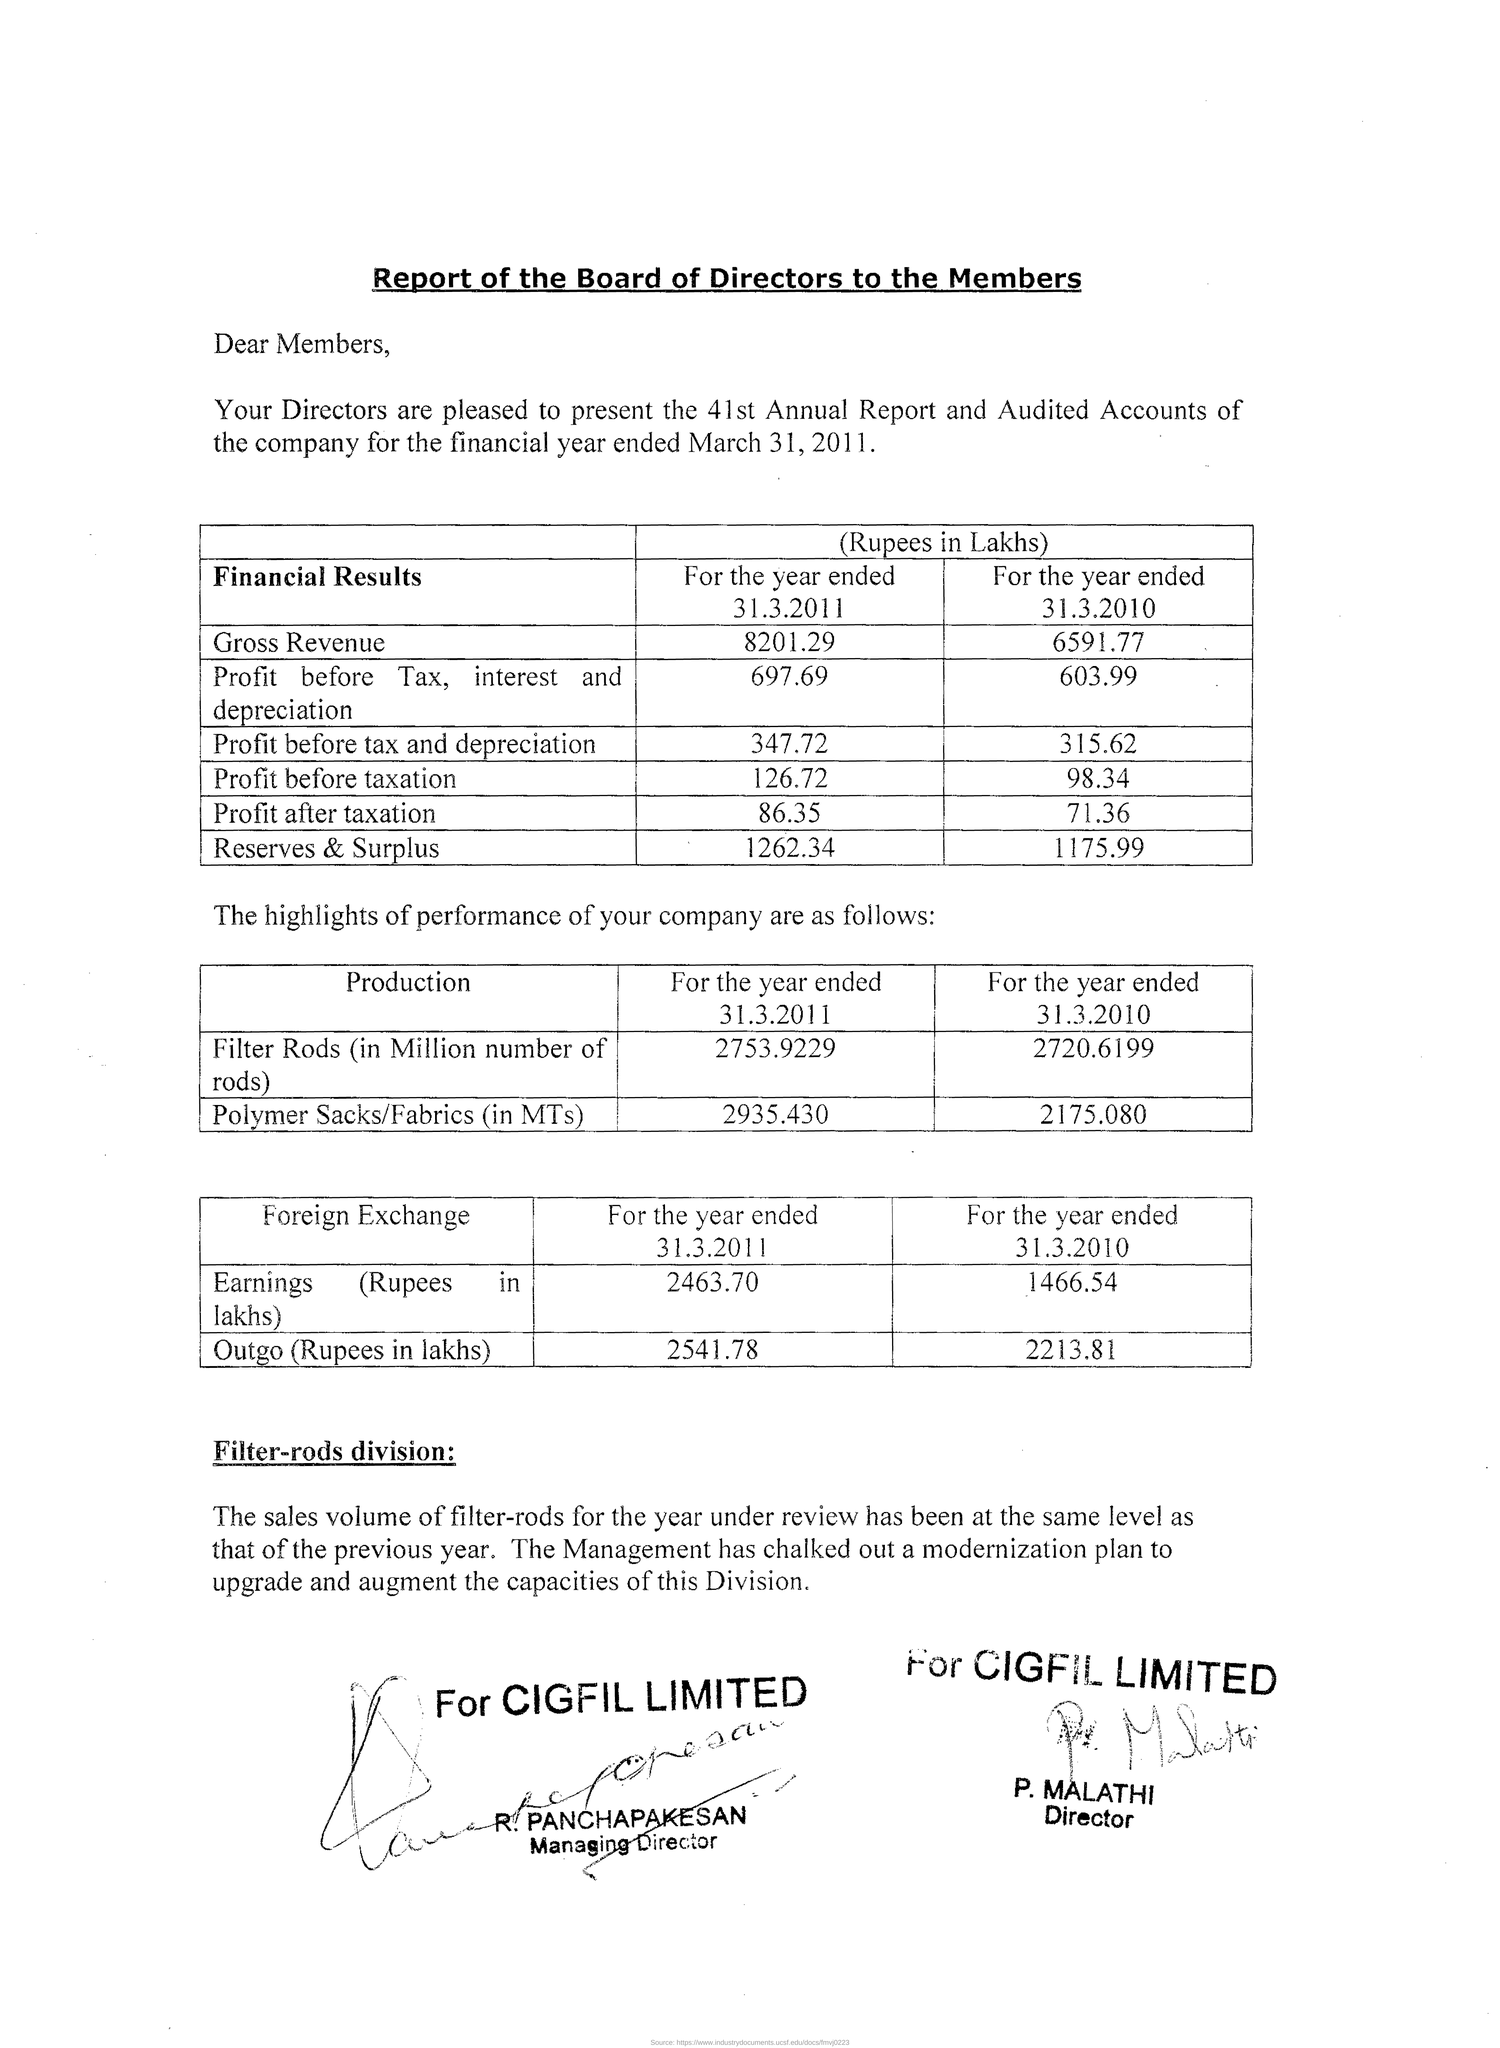What was the gross revenue in lakhs for the year ended 31.3.2011?
Make the answer very short. 8201.29. What was the gross revenue in lakhs for the year ended in 31.03.2010?
Ensure brevity in your answer.  6591.77. What was the profit before tax,interest and depreciation for the year 31.3.2011?
Your response must be concise. 697.69. What was the profit before tax,interest and depreciation for the year 31.3.2010?
Ensure brevity in your answer.  603.99. What was the profit before tax and depreciation for the year 31.3.2011?
Offer a very short reply. 347.72. What was the profit before tax and depreciation for the year 31.3.2010?
Your answer should be very brief. 315.62. What was the profit before taxation for the year 31.3.2011?
Your answer should be very brief. 126.72. What was the price before taxation for the year 31.3.2010?
Provide a succinct answer. 98.34. 